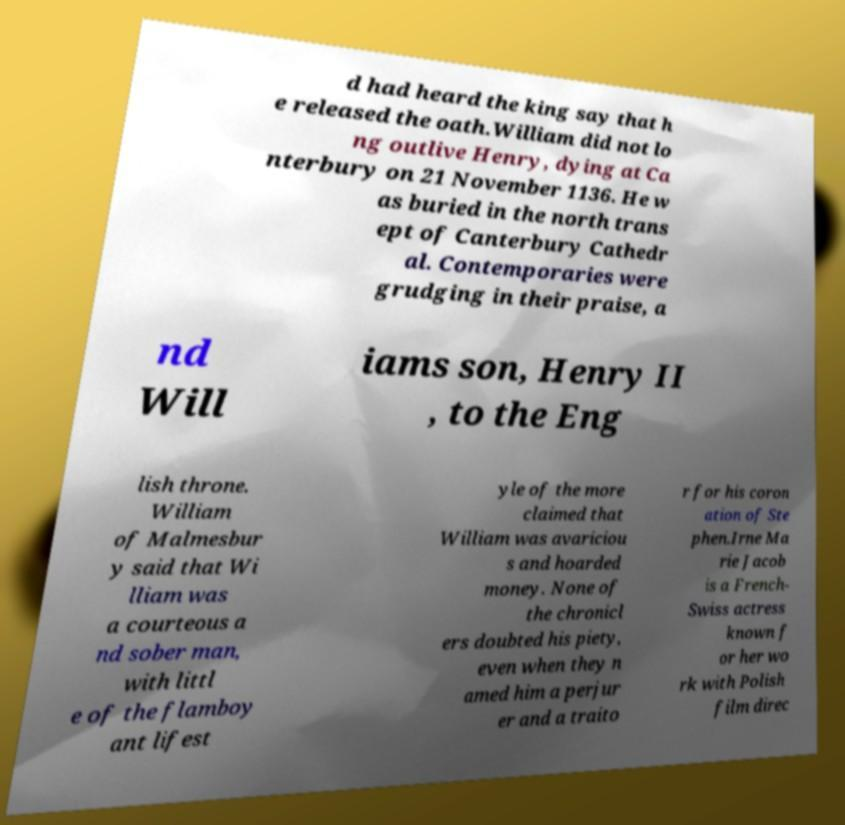Can you read and provide the text displayed in the image?This photo seems to have some interesting text. Can you extract and type it out for me? d had heard the king say that h e released the oath.William did not lo ng outlive Henry, dying at Ca nterbury on 21 November 1136. He w as buried in the north trans ept of Canterbury Cathedr al. Contemporaries were grudging in their praise, a nd Will iams son, Henry II , to the Eng lish throne. William of Malmesbur y said that Wi lliam was a courteous a nd sober man, with littl e of the flamboy ant lifest yle of the more claimed that William was avariciou s and hoarded money. None of the chronicl ers doubted his piety, even when they n amed him a perjur er and a traito r for his coron ation of Ste phen.Irne Ma rie Jacob is a French- Swiss actress known f or her wo rk with Polish film direc 